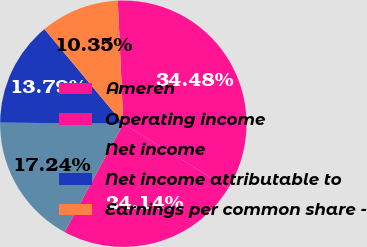Convert chart. <chart><loc_0><loc_0><loc_500><loc_500><pie_chart><fcel>Ameren<fcel>Operating income<fcel>Net income<fcel>Net income attributable to<fcel>Earnings per common share -<nl><fcel>34.48%<fcel>24.14%<fcel>17.24%<fcel>13.79%<fcel>10.35%<nl></chart> 